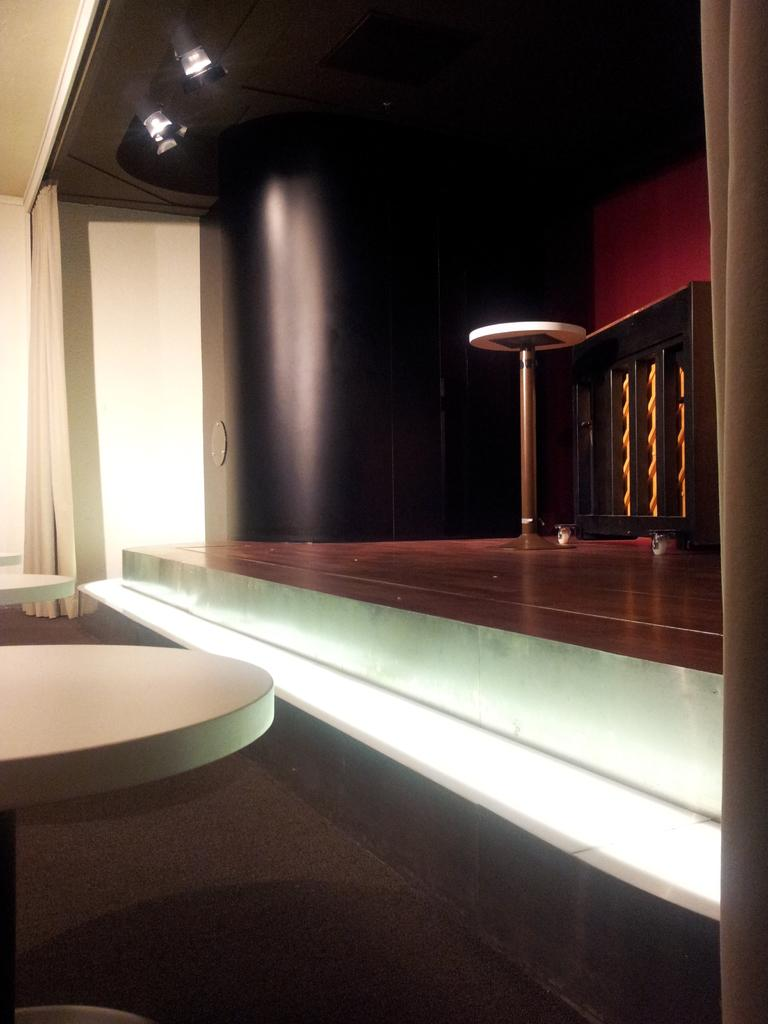What type of location is depicted in the image? The image shows an inside view of a building. What furniture can be seen in the image? There are tables in the image. What type of window treatment is present in the image? There is a curtain in the image. What is attached to the roof in the image? There are lights attached to the roof in the image. Can you see any connections between friends in the image? There is no reference to friends or any connections between them in the image. 